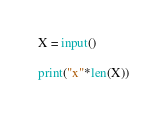Convert code to text. <code><loc_0><loc_0><loc_500><loc_500><_Python_>X = input()

print("x"*len(X))</code> 